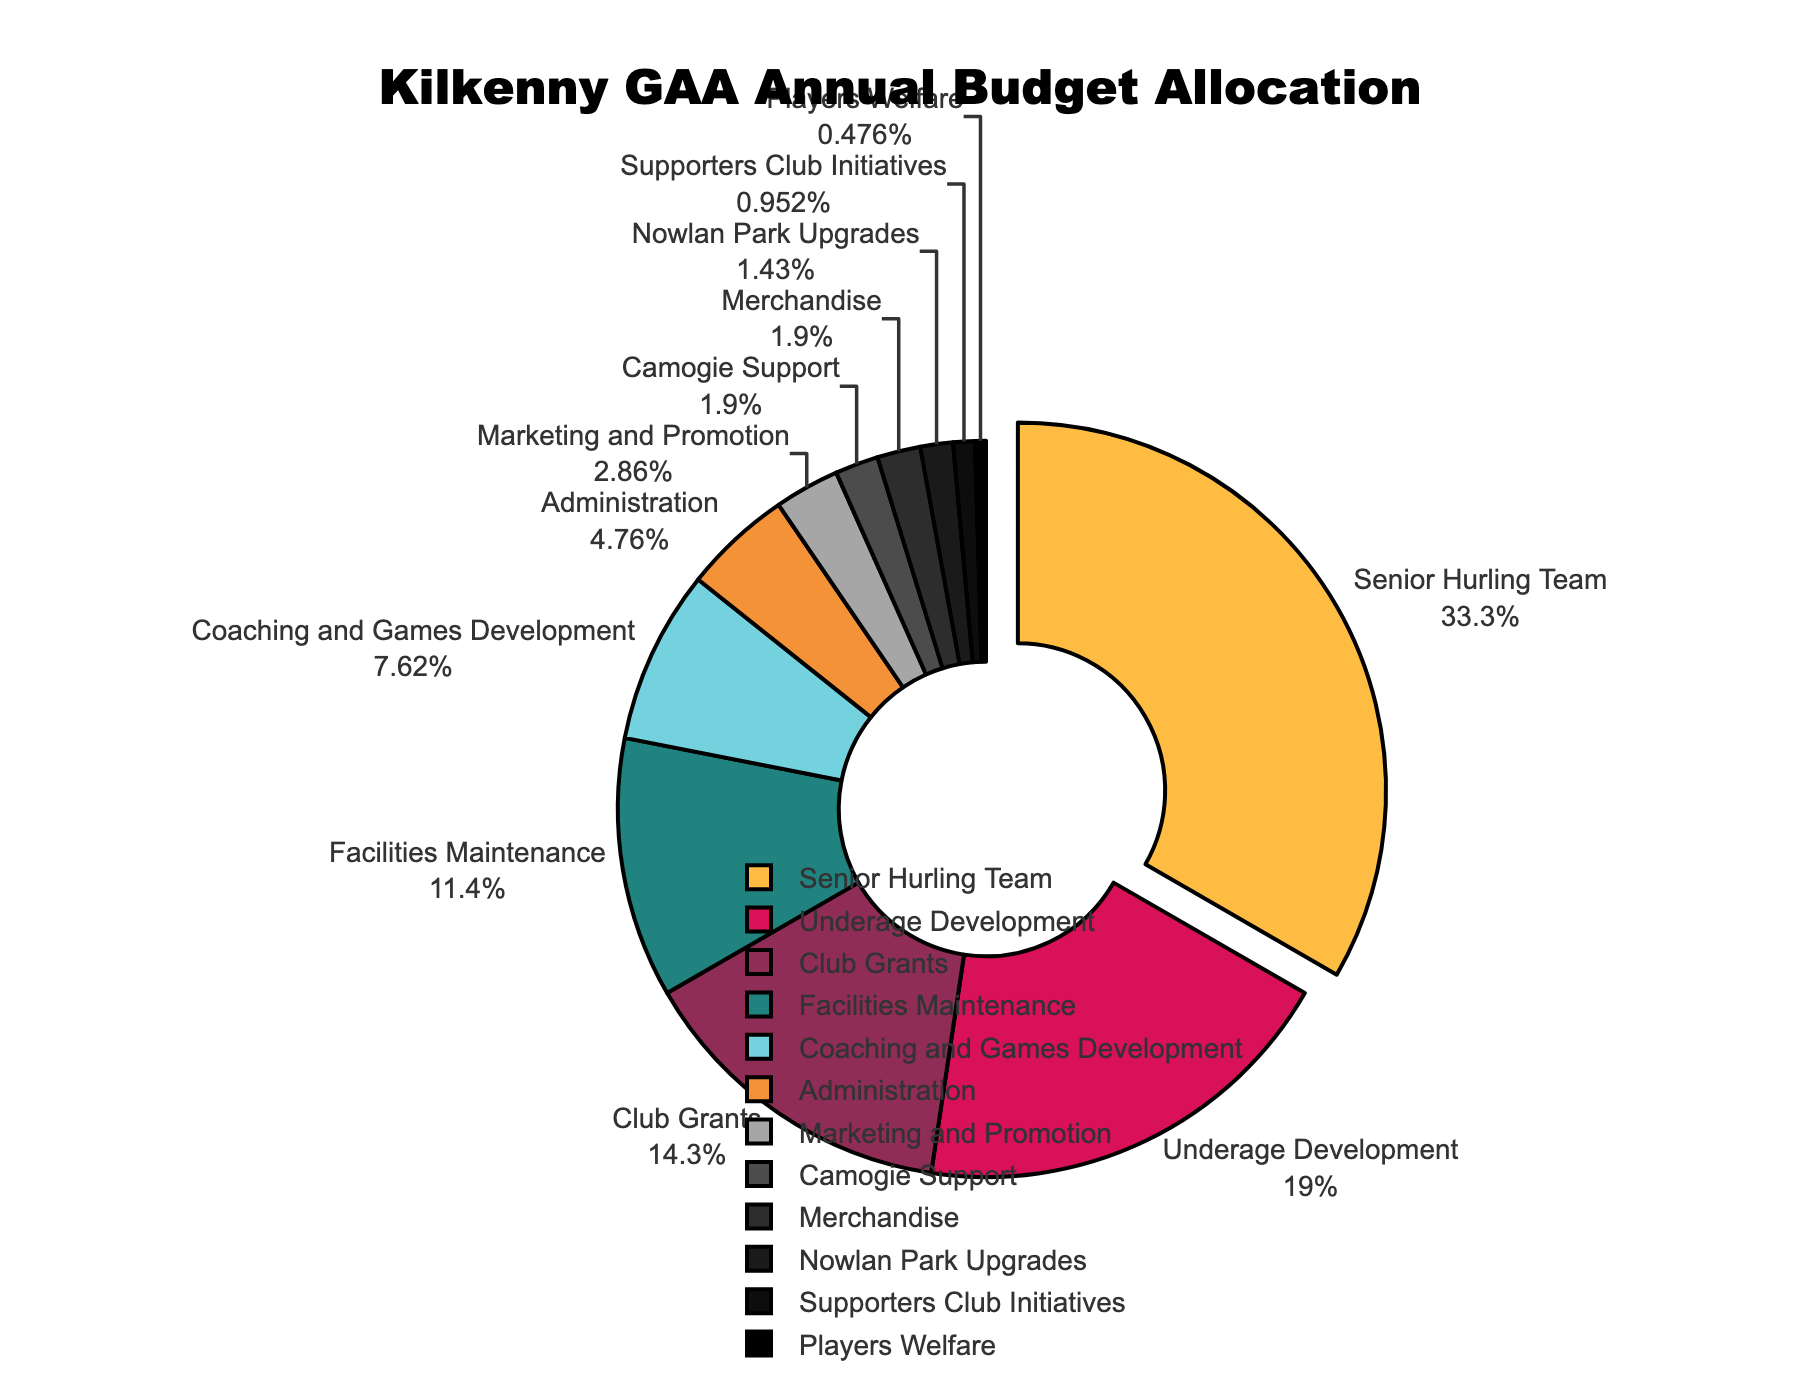What sector receives the largest portion of Kilkenny GAA's annual budget? The largest portion of the budget is allocated to the Senior Hurling Team, which is shown by the largest slice of the pie chart and is also pulled out for emphasis, accounting for 35% of the budget.
Answer: Senior Hurling Team What is the combined budget percentage allocated to Underage Development and Club Grants? The Underage Development sector receives 20% and the Club Grants sector receives 15%. Adding these percentages together gives 20% + 15% = 35%.
Answer: 35% Which sector has the smallest budget allocation and what is its percentage? The sector with the smallest budget allocation is Players Welfare, which accounts for 0.5% of the total budget. This is indicated by the smallest slice in the pie chart.
Answer: Players Welfare, 0.5% Is the budget for Merchandise greater than or equal to the budget for Camogie Support? The budget for Merchandise is 2%, and the budget for Camogie Support is also 2%. Since both percentages are equal, the budget for Merchandise is equal to the budget for Camogie Support.
Answer: Equal What is the total percentage allocated to sectors related to facilities: Facilities Maintenance and Nowlan Park Upgrades? The Facilities Maintenance sector receives 12% and the Nowlan Park Upgrades sector receives 1.5%. Adding these percentages together gives 12% + 1.5% = 13.5%.
Answer: 13.5% Which sector has the second-largest budget allocation and what is its percentage? The second-largest budget allocation goes to Underage Development, which receives 20% of the total budget. This is apparent from the pie chart where Underage Development is the second largest slice.
Answer: Underage Development, 20% How does the budget allocation for Marketing and Promotion compare to Administration? The Marketing and Promotion sector receives 3%, while the Administration sector receives 5%. Therefore, Administration receives a higher budget allocation compared to Marketing and Promotion.
Answer: Administration > Marketing and Promotion What is the combined budget percentage allocated to sectors that receive exactly 2%? The sectors that receive exactly 2% are Camogie Support and Merchandise. Adding these percentages together gives 2% + 2% = 4%.
Answer: 4% What proportion of the budget is allocated to sports-related sectors (Senior Hurling Team, Underage Development, Camogie Support)? The Senior Hurling Team gets 35%, Underage Development gets 20%, and Camogie Support gets 2%. Adding these percentages together yields 35% + 20% + 2% = 57%.
Answer: 57% Which sector's budget allocation falls just below 10% and what is its exact value? The Coaching and Games Development sector's budget allocation falls just below 10% and its exact value as indicated on the pie chart is 8%.
Answer: Coaching and Games Development, 8% 